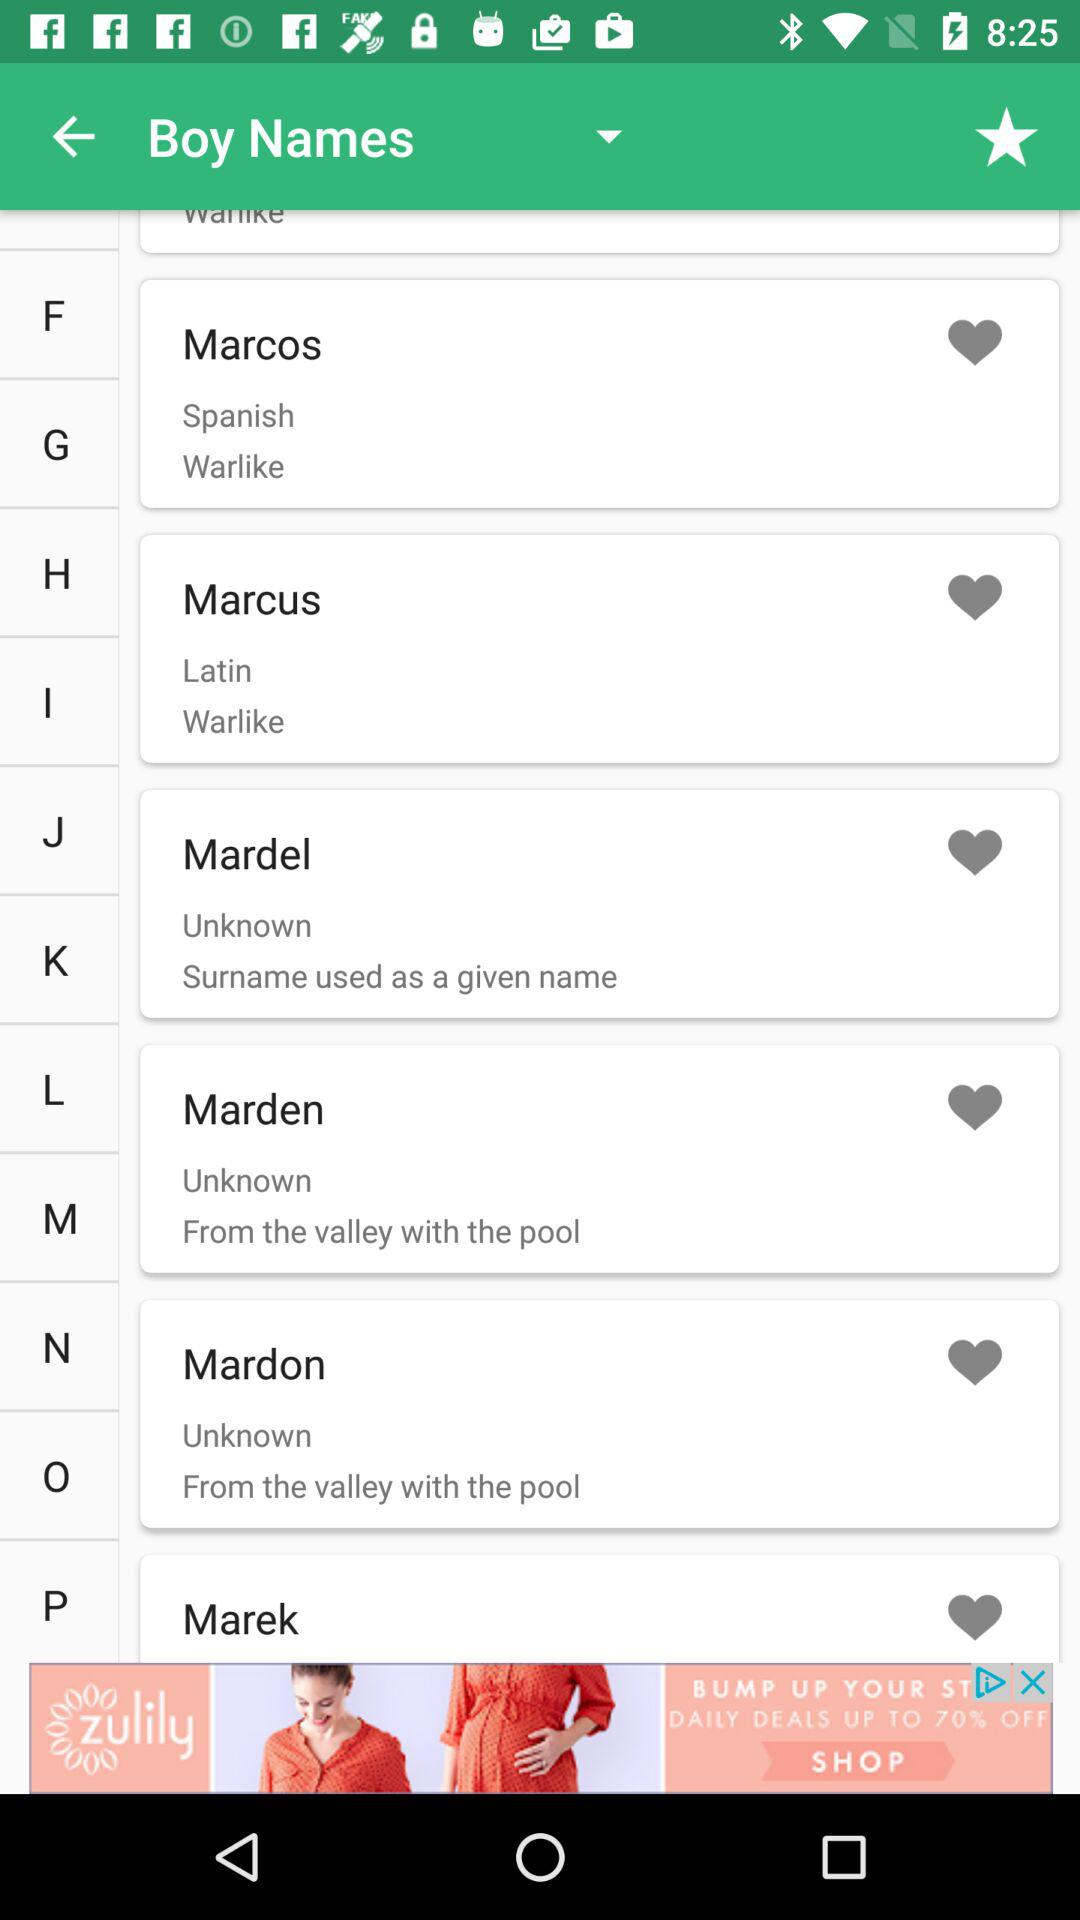What Latin word is there? The Latin word is "Marcus". 